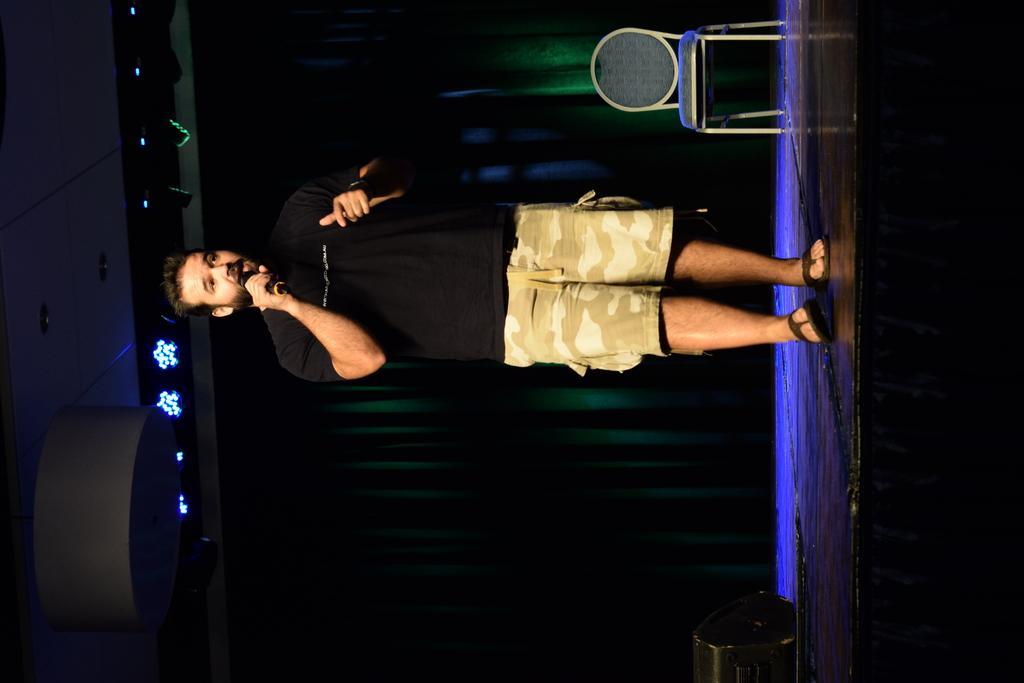In one or two sentences, can you explain what this image depicts? In this image we can see a person, microphone, chair and other objects. In the background of the image there is the curtain. On the left side of the image there is the ceiling, lights and other objects. On the right side of the image there is a black surface. 